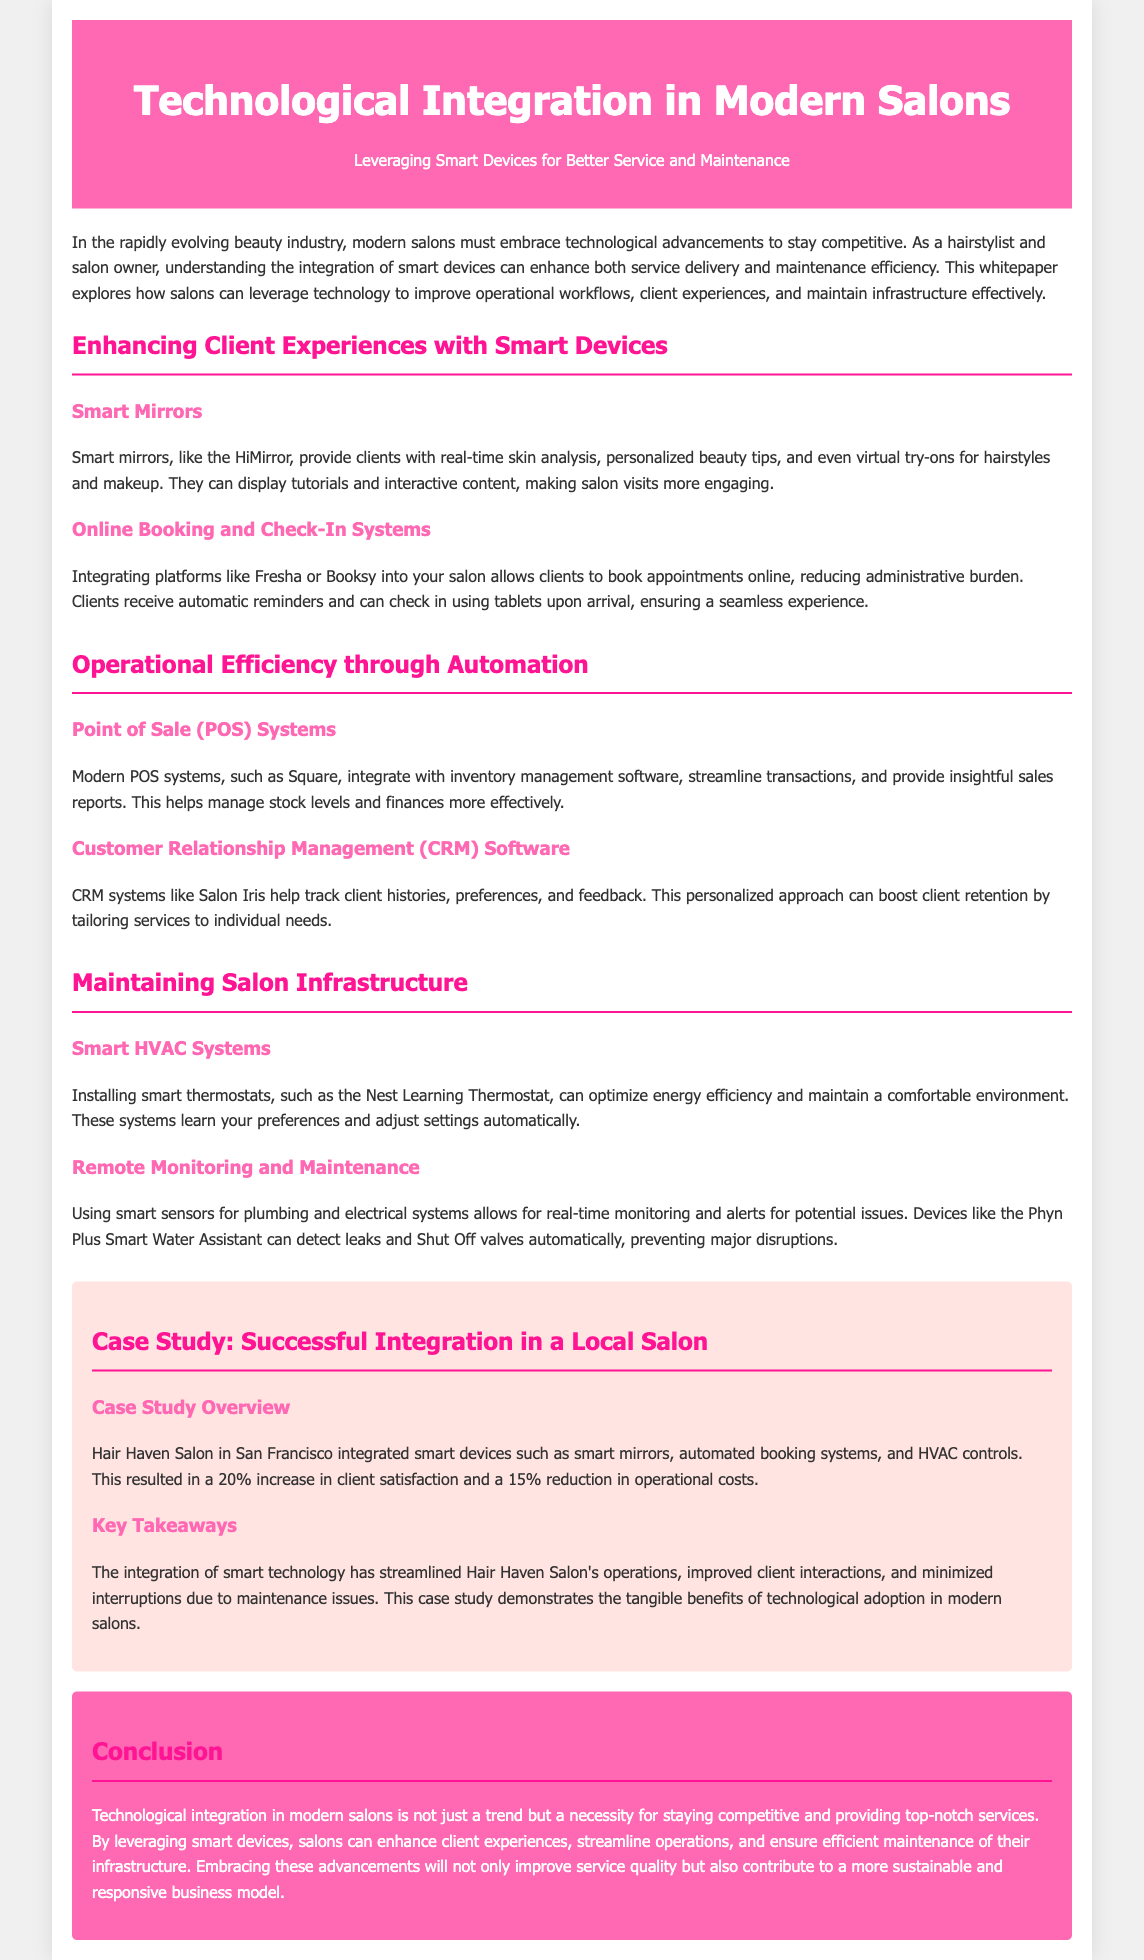what is the title of the whitepaper? The title of the whitepaper is stated prominently at the top, making it easily recognizable.
Answer: Technological Integration in Modern Salons what technology does the whitepaper suggest for client experiences? The document presents smart mirrors as a technology enhancing client experiences in salons.
Answer: Smart mirrors what is a benefit of smart HVAC systems mentioned? The document states that smart HVAC systems optimize energy efficiency and maintain comfort.
Answer: Energy efficiency how much did client satisfaction increase at Hair Haven Salon? The case study highlights a specific percentage increase in client satisfaction post-integration.
Answer: 20% what software is mentioned for online booking systems? The whitepaper names a specific platform for online booking, contributing to operational efficiency.
Answer: Fresha how much did operational costs decrease at Hair Haven Salon? The document specifies a percentage reduction in operational costs due to integration of smart devices.
Answer: 15% what type of sensors are discussed for plumbing and electrical monitoring? The whitepaper describes smart sensors for real-time monitoring of infrastructure.
Answer: Smart sensors what learning feature does the Nest Learning Thermostat have? The document points out that the thermostat adjusts settings based on learned preferences.
Answer: Learns preferences what is the primary focus of the whitepaper? The whitepaper revolves around the integration of certain technologies to improve salon services and maintenance.
Answer: Technological integration 